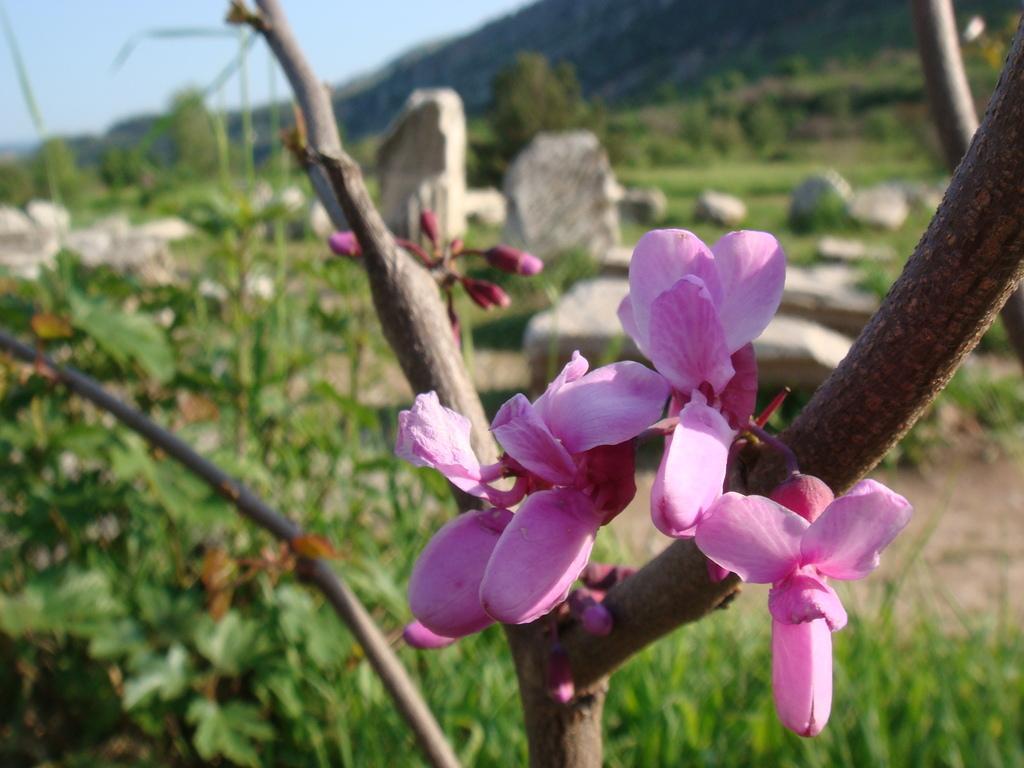Can you describe this image briefly? In this image we can see pink flowers, there is the bud, there are the plants, there are the rocks, at above here is the sky. 